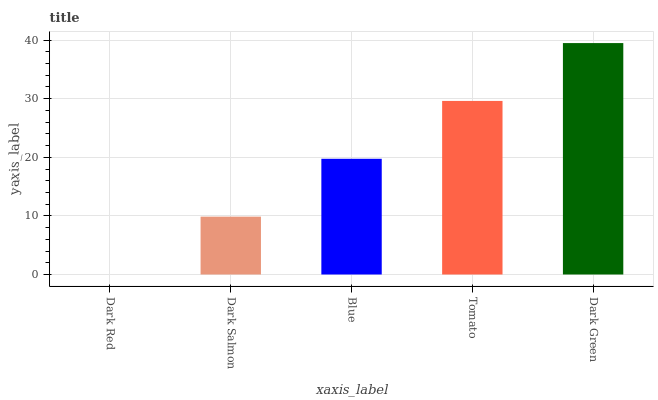Is Dark Salmon the minimum?
Answer yes or no. No. Is Dark Salmon the maximum?
Answer yes or no. No. Is Dark Salmon greater than Dark Red?
Answer yes or no. Yes. Is Dark Red less than Dark Salmon?
Answer yes or no. Yes. Is Dark Red greater than Dark Salmon?
Answer yes or no. No. Is Dark Salmon less than Dark Red?
Answer yes or no. No. Is Blue the high median?
Answer yes or no. Yes. Is Blue the low median?
Answer yes or no. Yes. Is Tomato the high median?
Answer yes or no. No. Is Tomato the low median?
Answer yes or no. No. 